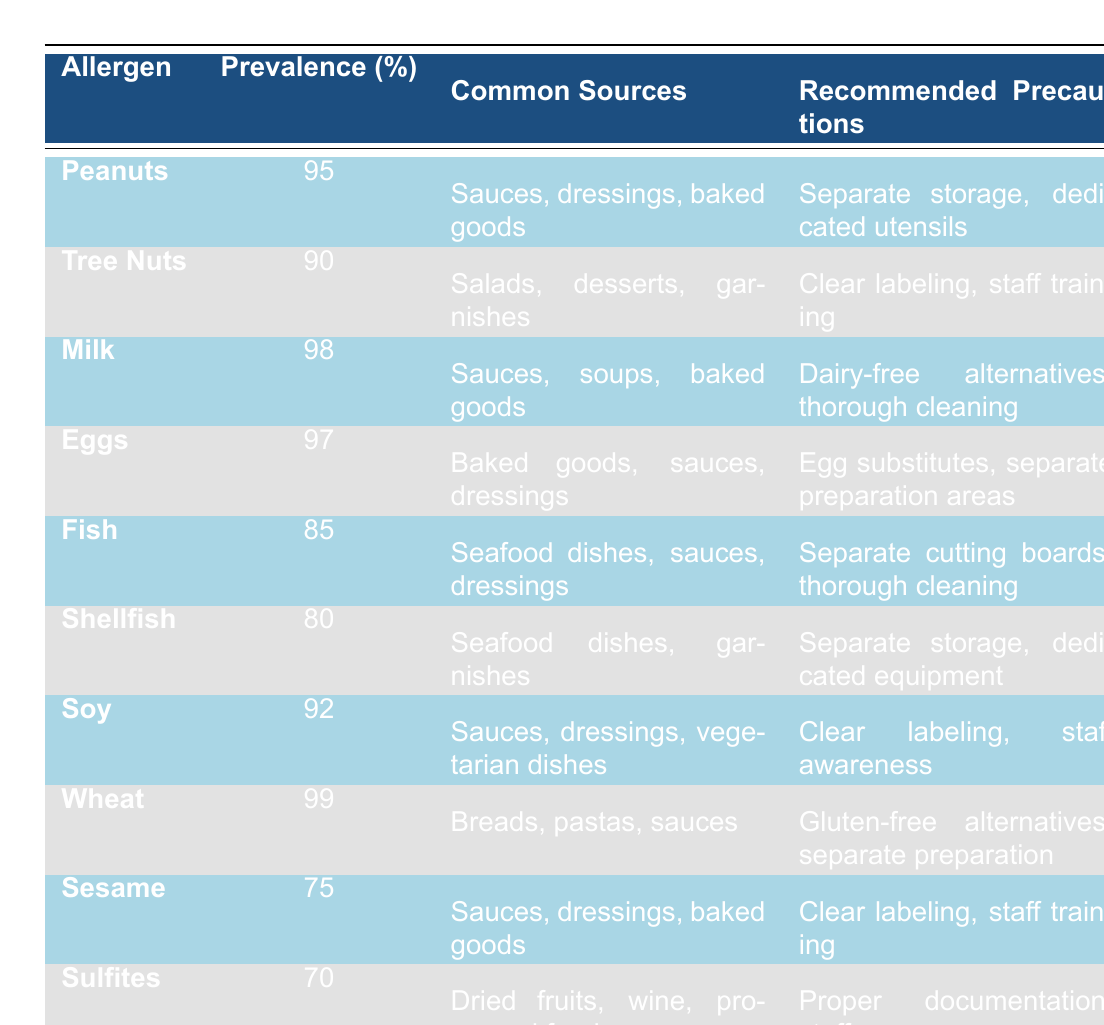What is the most prevalent allergen in restaurant kitchens? The highest percentage listed in the "Prevalence in Kitchens (%)" column is 99, which corresponds to Wheat.
Answer: Wheat Which allergens have a prevalence rate of 80% or lower? Looking at the "Prevalence in Kitchens (%)" column, Shellfish at 80%, Sesame at 75%, and Sulfites at 70% are the only ones with a prevalence of 80% or lower.
Answer: Shellfish, Sesame, Sulfites What percentage of kitchens have Milk as an allergen? The "Prevalence in Kitchens (%)" column shows that Milk has a prevalence of 98%.
Answer: 98% Are Eggs more prevalent than Fish in kitchens? Comparing the prevalence rates for Eggs (97%) and Fish (85%), we see that Eggs have a higher prevalence than Fish.
Answer: Yes What are the common sources of allergens that involve sauces or dressings? The allergens listed with "Sauces" or "Dressings" in the "Common Sources" column are Peanuts, Eggs, Fish, Soy, Sesame, and Sulfites.
Answer: Peanuts, Eggs, Fish, Soy, Sesame, Sulfites How many allergens have a prevalence of 90% or higher? By counting the allergens with a prevalence rate of 90% or higher: Peanuts (95%), Tree Nuts (90%), Milk (98%), Eggs (97%), Soy (92%), and Wheat (99%), there are a total of 6 allergens.
Answer: 6 What precautions are recommended for handling Shellfish? The table indicates that the recommended precautions for handling Shellfish include separate storage and dedicated equipment.
Answer: Separate storage, dedicated equipment Is the prevalence of Soy higher or lower than that of Tree Nuts? The prevalence for Soy is 92%, and for Tree Nuts, it is 90%, indicating that Soy has a higher prevalence.
Answer: Higher What is the average prevalence of allergens that primarily come from seafood (Fish and Shellfish)? The average of Fish (85%) and Shellfish (80%) is calculated as (85 + 80) / 2 = 82.5%.
Answer: 82.5% Which allergens require separate preparation areas? The allergens that require separate preparation areas are Eggs and Fish, as indicated in their respective precautions.
Answer: Eggs, Fish 